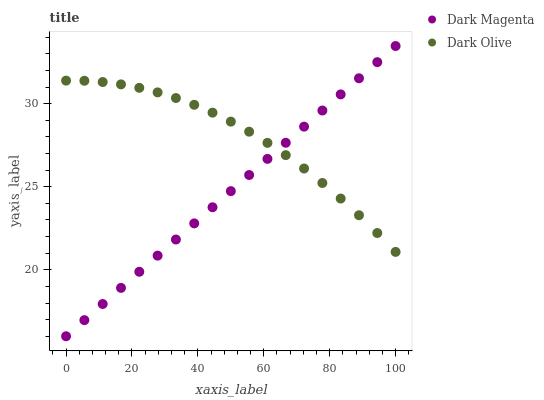Does Dark Magenta have the minimum area under the curve?
Answer yes or no. Yes. Does Dark Olive have the maximum area under the curve?
Answer yes or no. Yes. Does Dark Magenta have the maximum area under the curve?
Answer yes or no. No. Is Dark Magenta the smoothest?
Answer yes or no. Yes. Is Dark Olive the roughest?
Answer yes or no. Yes. Is Dark Magenta the roughest?
Answer yes or no. No. Does Dark Magenta have the lowest value?
Answer yes or no. Yes. Does Dark Magenta have the highest value?
Answer yes or no. Yes. Does Dark Olive intersect Dark Magenta?
Answer yes or no. Yes. Is Dark Olive less than Dark Magenta?
Answer yes or no. No. Is Dark Olive greater than Dark Magenta?
Answer yes or no. No. 